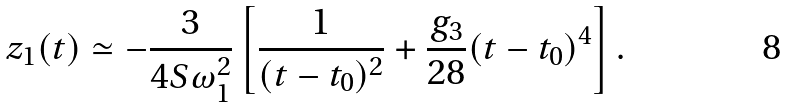<formula> <loc_0><loc_0><loc_500><loc_500>z _ { 1 } ( t ) \simeq - \frac { 3 } { 4 S \omega _ { 1 } ^ { 2 } } \left [ \frac { 1 } { ( t - t _ { 0 } ) ^ { 2 } } + \frac { g _ { 3 } } { 2 8 } ( t - t _ { 0 } ) ^ { 4 } \right ] .</formula> 